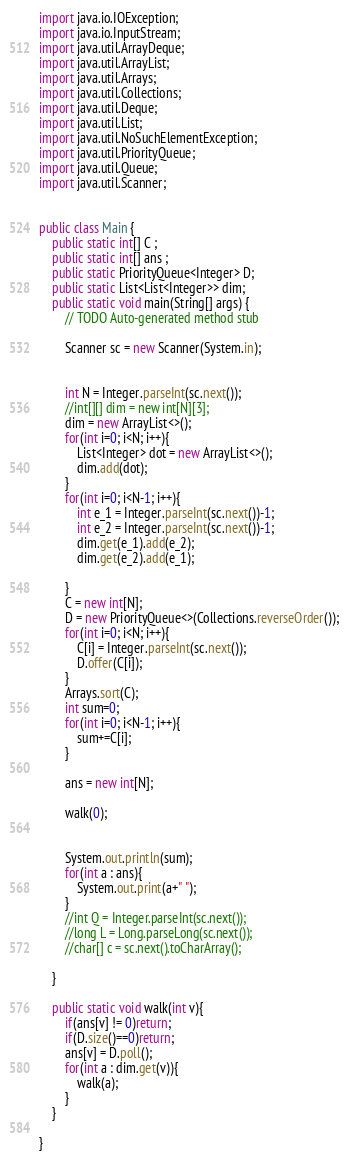<code> <loc_0><loc_0><loc_500><loc_500><_Java_>import java.io.IOException;
import java.io.InputStream;
import java.util.ArrayDeque;
import java.util.ArrayList;
import java.util.Arrays;
import java.util.Collections;
import java.util.Deque;
import java.util.List;
import java.util.NoSuchElementException;
import java.util.PriorityQueue;
import java.util.Queue;
import java.util.Scanner;
 
 
public class Main {
	public static int[] C ;
	public static int[] ans ;
	public static PriorityQueue<Integer> D;
	public static List<List<Integer>> dim;
	public static void main(String[] args) {
		// TODO Auto-generated method stub
		
		Scanner sc = new Scanner(System.in);
		
		
		int N = Integer.parseInt(sc.next());
		//int[][] dim = new int[N][3];
		dim = new ArrayList<>();
		for(int i=0; i<N; i++){
			List<Integer> dot = new ArrayList<>();
			dim.add(dot);
		}
		for(int i=0; i<N-1; i++){
			int e_1 = Integer.parseInt(sc.next())-1;
			int e_2 = Integer.parseInt(sc.next())-1;
			dim.get(e_1).add(e_2);
			dim.get(e_2).add(e_1);

		}
		C = new int[N];
		D = new PriorityQueue<>(Collections.reverseOrder());
		for(int i=0; i<N; i++){
			C[i] = Integer.parseInt(sc.next());
			D.offer(C[i]);
		}
		Arrays.sort(C);
		int sum=0;
		for(int i=0; i<N-1; i++){
			sum+=C[i];
		}
		
		ans = new int[N];
		
		walk(0);
		

		System.out.println(sum);
		for(int a : ans){
			System.out.print(a+" ");
		}
		//int Q = Integer.parseInt(sc.next());
		//long L = Long.parseLong(sc.next());
		//char[] c = sc.next().toCharArray();

	}
	
	public static void walk(int v){
		if(ans[v] != 0)return;
		if(D.size()==0)return;
		ans[v] = D.poll();
		for(int a : dim.get(v)){
			walk(a);
		}
	}
	
}

</code> 